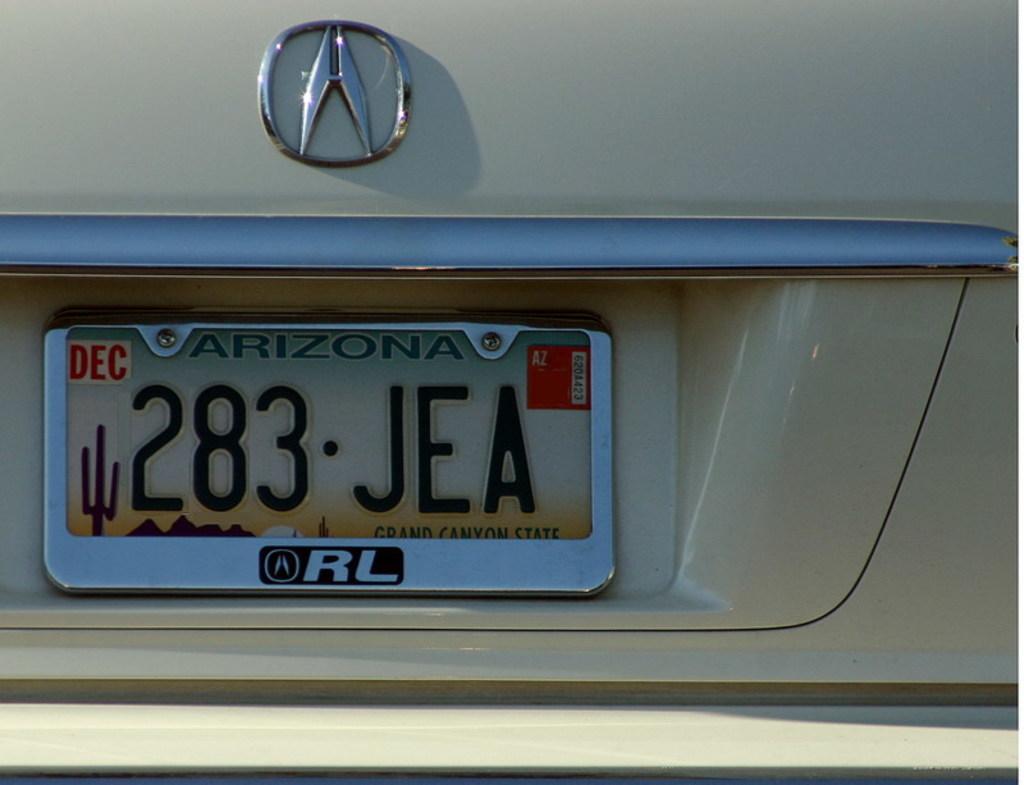What state is this car registered to?
Offer a very short reply. Arizona. What month does this car's registration expire?
Provide a succinct answer. December. 